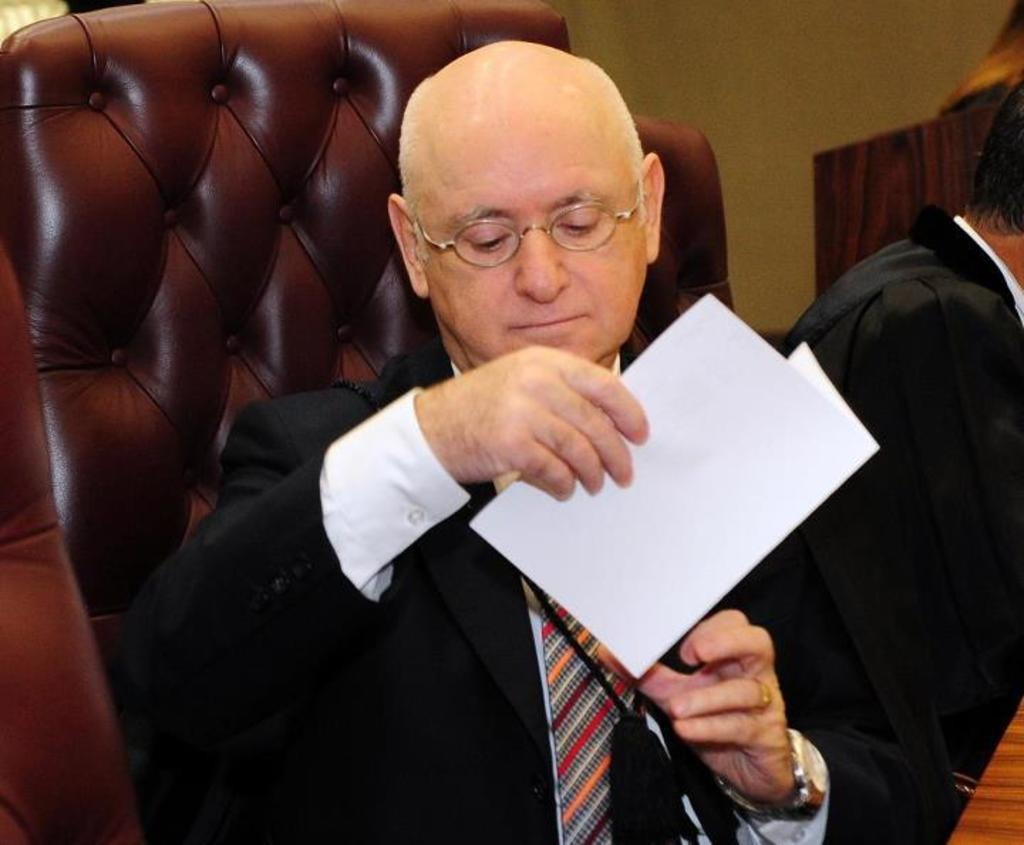What can be seen in the foreground of the picture? In the foreground of the picture, there are men, a table, and chairs. What is the person in the center of the picture doing? The person in the center of the picture is holding a paper. What is visible in the background of the picture? There is a wall in the background of the picture. How many flies can be seen on the person's head in the image? There are no flies present in the image, and therefore no such activity can be observed. What type of side dish is being served on the table in the image? The provided facts do not mention any side dishes or food items on the table; only a table, chairs, and men are mentioned. 